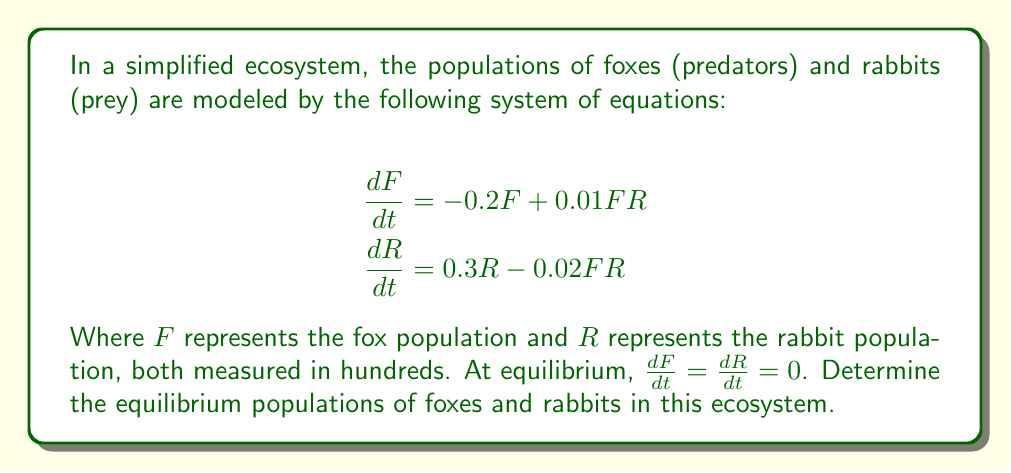What is the answer to this math problem? To find the equilibrium populations, we need to solve the system of equations when both derivatives are set to zero:

1) Set both equations to zero:
   $$0 = -0.2F + 0.01FR$$
   $$0 = 0.3R - 0.02FR$$

2) From the first equation:
   $$0.2F = 0.01FR$$
   $$20 = R$$ (if $F \neq 0$)

3) Substitute $R = 20$ into the second equation:
   $$0 = 0.3(20) - 0.02F(20)$$
   $$0 = 6 - 0.4F$$
   $$0.4F = 6$$
   $$F = 15$$

4) Check the solution in both original equations:
   For foxes: $-0.2(15) + 0.01(15)(20) = -3 + 3 = 0$
   For rabbits: $0.3(20) - 0.02(15)(20) = 6 - 6 = 0$

Therefore, the equilibrium populations are 15 hundred foxes and 20 hundred rabbits.
Answer: $F = 15, R = 20$ 